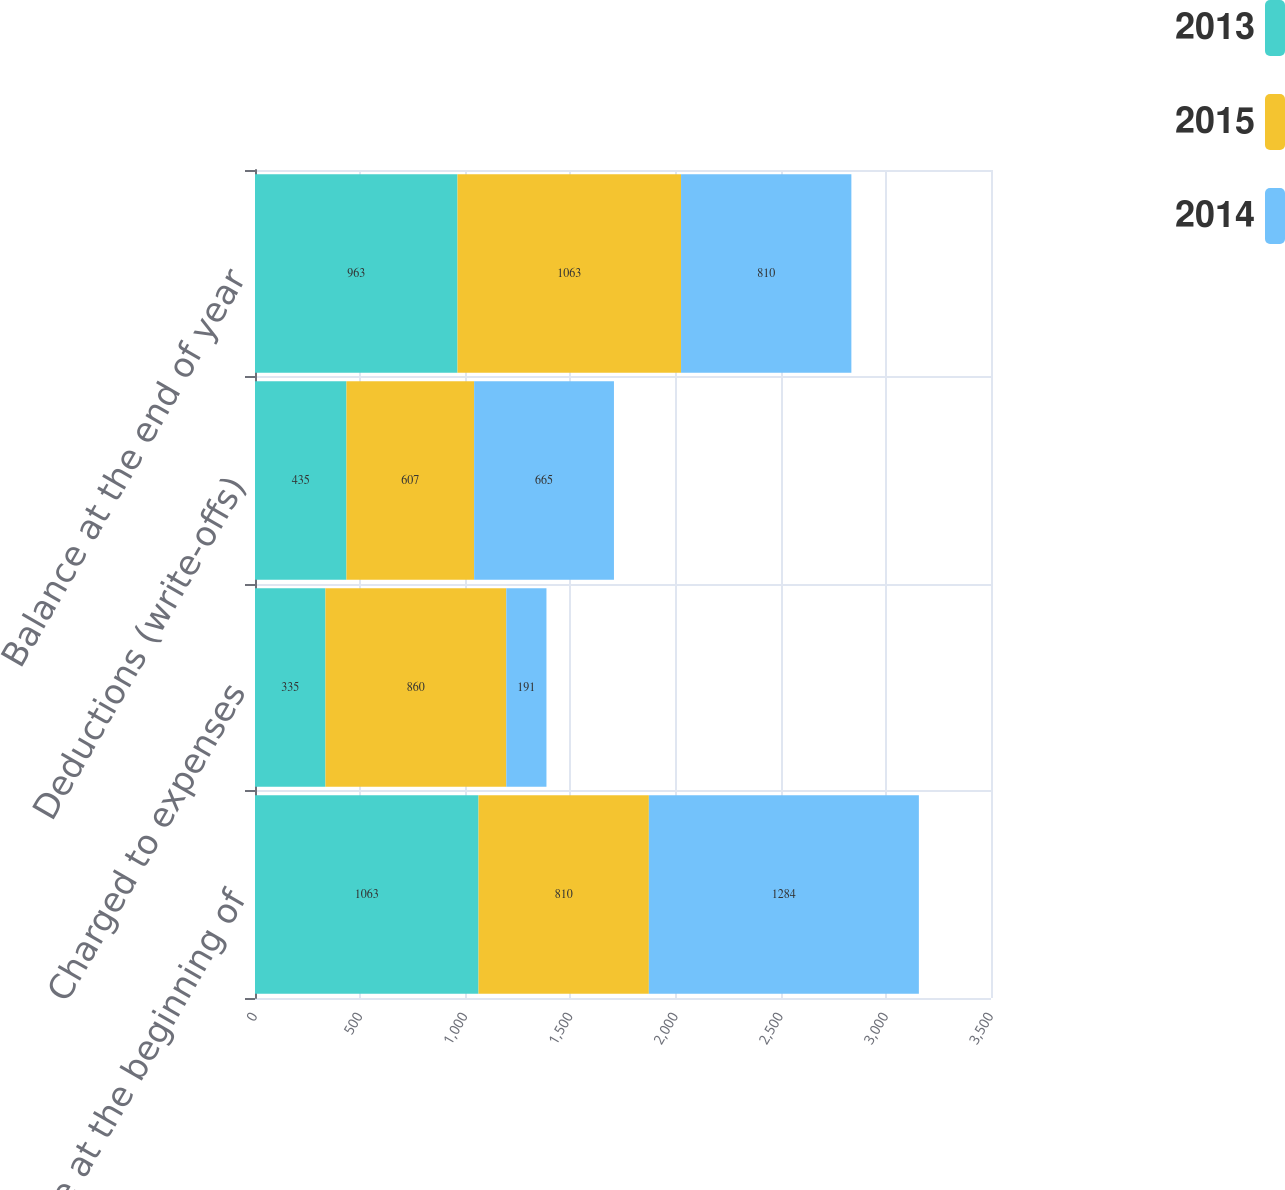<chart> <loc_0><loc_0><loc_500><loc_500><stacked_bar_chart><ecel><fcel>Balance at the beginning of<fcel>Charged to expenses<fcel>Deductions (write-offs)<fcel>Balance at the end of year<nl><fcel>2013<fcel>1063<fcel>335<fcel>435<fcel>963<nl><fcel>2015<fcel>810<fcel>860<fcel>607<fcel>1063<nl><fcel>2014<fcel>1284<fcel>191<fcel>665<fcel>810<nl></chart> 